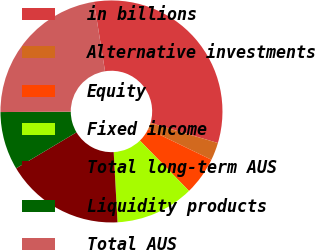<chart> <loc_0><loc_0><loc_500><loc_500><pie_chart><fcel>in billions<fcel>Alternative investments<fcel>Equity<fcel>Fixed income<fcel>Total long-term AUS<fcel>Liquidity products<fcel>Total AUS<nl><fcel>32.11%<fcel>2.58%<fcel>5.53%<fcel>11.44%<fcel>17.3%<fcel>8.48%<fcel>22.56%<nl></chart> 